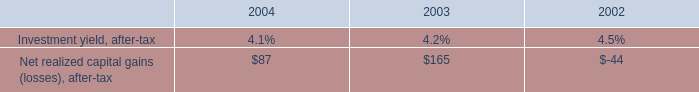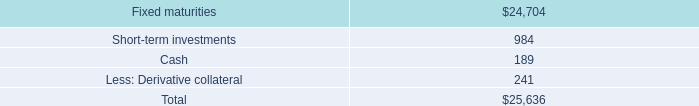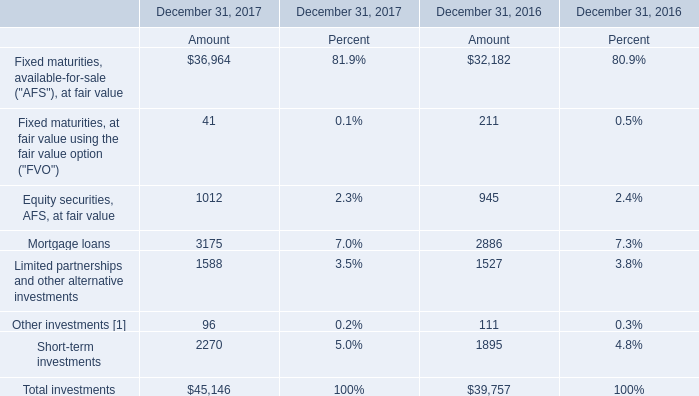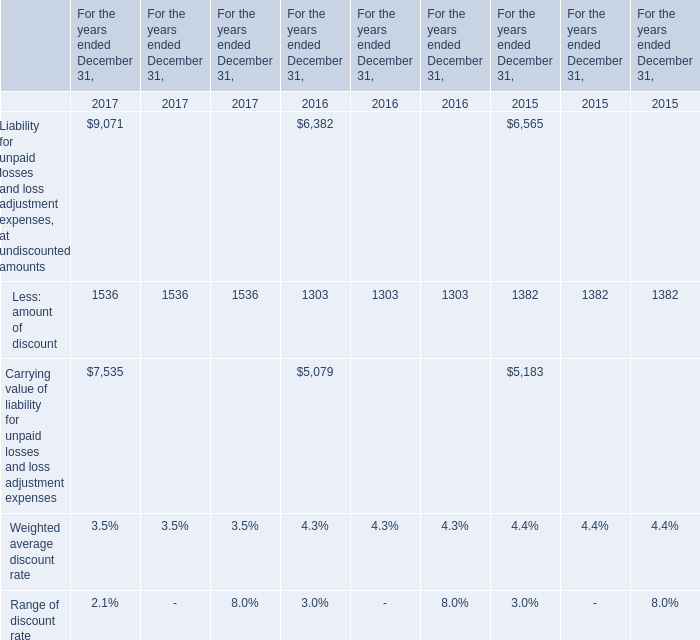Which year is Mortgage loans greater than 3000 ? 
Answer: 2017. 